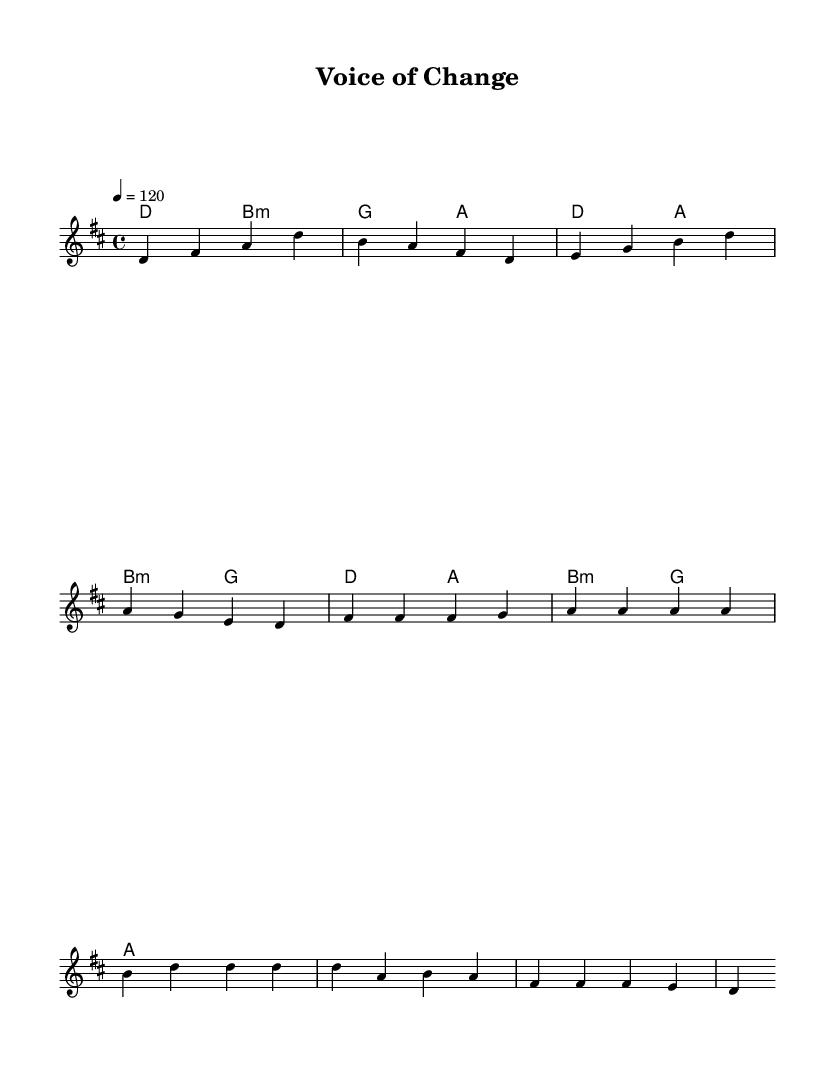What is the key signature of this music? The key signature is D major, which has two sharps (F# and C#). This is indicated by the placement of the sharps at the beginning of the staff.
Answer: D major What is the time signature of this music? The time signature is 4/4, as shown at the beginning of the sheet music. This means there are four beats in a measure, and each quarter note receives one beat.
Answer: 4/4 What is the tempo marking of this piece? The tempo marking is 120 beats per minute, indicated by the number 4 = 120 at the beginning. It specifies how fast the piece should be played.
Answer: 120 How many measures are in the verse section? The verse section consists of four measures, which can be counted by examining the bars in the melody part, from the start of the piece until the pre-chorus begins.
Answer: 4 What chord is played in the first measure of the verse? The chord played in the first measure of the verse is D major, indicated by the notation in the harmonies section along with the melody notes that align with this chord.
Answer: D Which section follows the pre-chorus? The chorus section follows the pre-chorus, which is evident from the structure of the song where the melody shifts from pre-chorus to chorus in the provided score.
Answer: Chorus What is the last chord in the chorus? The last chord in the chorus is A major, indicated by the "a2" marking at the end of the last measure in the chorus of the harmonies section.
Answer: A 